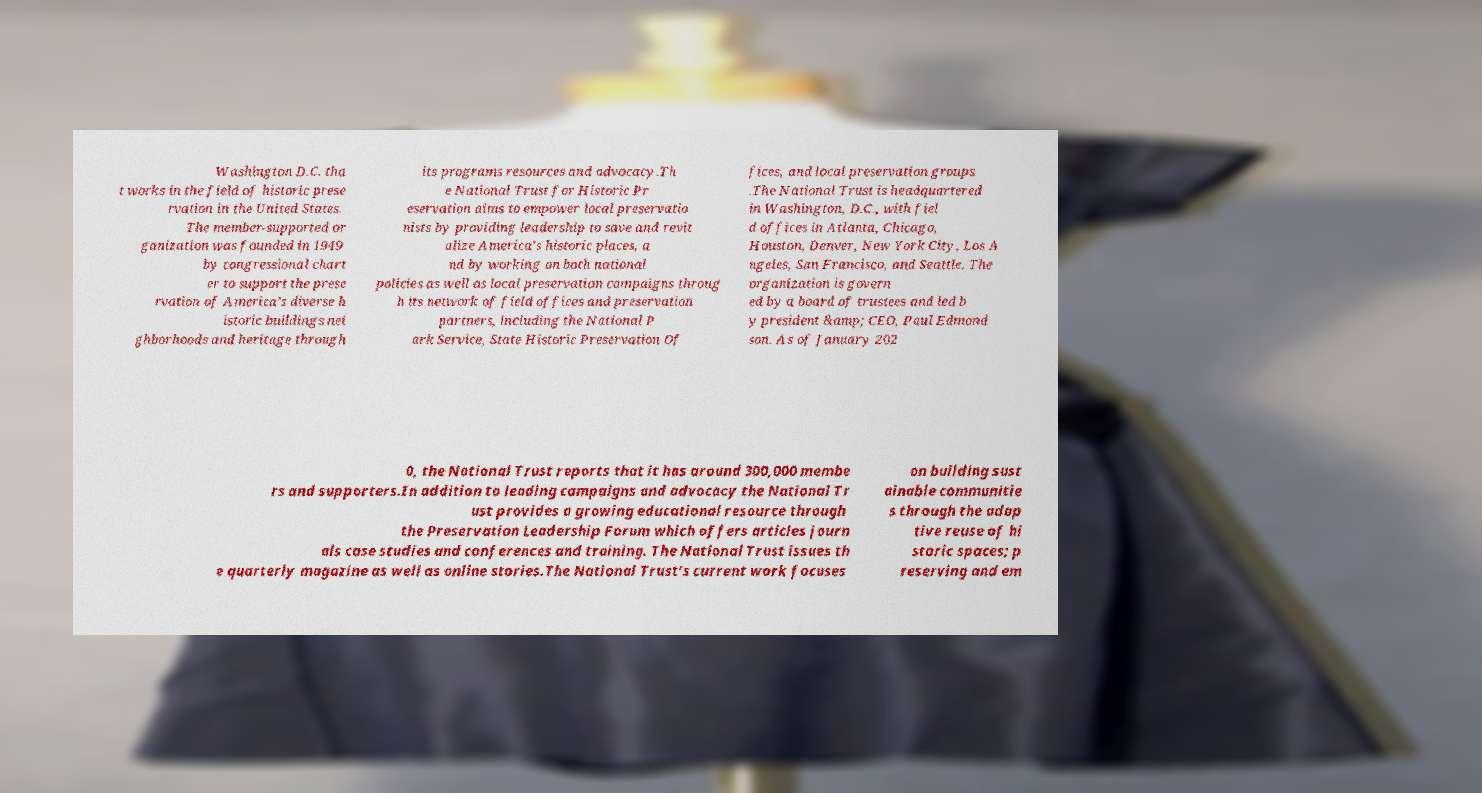There's text embedded in this image that I need extracted. Can you transcribe it verbatim? Washington D.C. tha t works in the field of historic prese rvation in the United States. The member-supported or ganization was founded in 1949 by congressional chart er to support the prese rvation of America’s diverse h istoric buildings nei ghborhoods and heritage through its programs resources and advocacy.Th e National Trust for Historic Pr eservation aims to empower local preservatio nists by providing leadership to save and revit alize America's historic places, a nd by working on both national policies as well as local preservation campaigns throug h its network of field offices and preservation partners, including the National P ark Service, State Historic Preservation Of fices, and local preservation groups .The National Trust is headquartered in Washington, D.C., with fiel d offices in Atlanta, Chicago, Houston, Denver, New York City, Los A ngeles, San Francisco, and Seattle. The organization is govern ed by a board of trustees and led b y president &amp; CEO, Paul Edmond son. As of January 202 0, the National Trust reports that it has around 300,000 membe rs and supporters.In addition to leading campaigns and advocacy the National Tr ust provides a growing educational resource through the Preservation Leadership Forum which offers articles journ als case studies and conferences and training. The National Trust issues th e quarterly magazine as well as online stories.The National Trust’s current work focuses on building sust ainable communitie s through the adap tive reuse of hi storic spaces; p reserving and em 